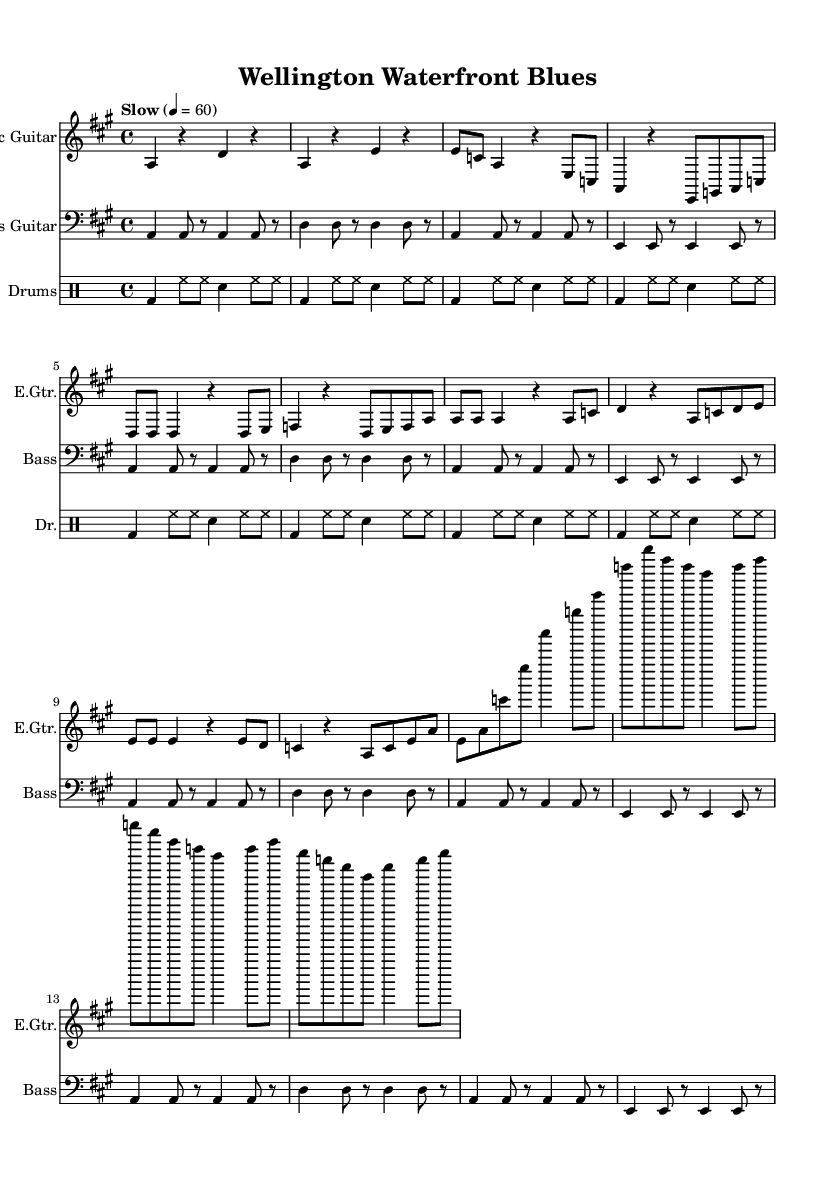What is the key signature of this music? The key signature of this music is A major, which has three sharps: F sharp, C sharp, and G sharp.
Answer: A major What is the time signature of the piece? The time signature indicated in the music is 4/4, meaning there are four beats in each measure and the quarter note gets one beat.
Answer: 4/4 What is the tempo marking for the piece? The tempo marking given is "Slow" with a metronomic tempo of 60 beats per minute, indicating a relaxed pace for playing the music.
Answer: Slow How many measures are in the guitar solo section? The guitar solo section consists of 4 measures, as indicated by the sequence of notes and rests after the chorus. Each set of bar lines separates the measures.
Answer: 4 Which instruments are included in this arrangement? The arrangement includes Electric Guitar, Bass Guitar, and Drums, as indicated by their respective instrument titles at the beginning of each staff.
Answer: Electric Guitar, Bass Guitar, Drums What is the overall structure of the piece? The piece follows a structure of Intro, Verse, Chorus, and Guitar Solo, each denoted by the arrangement of musical sections that repeat or vary throughout.
Answer: Intro, Verse, Chorus, Guitar Solo What type of blues is this music categorized as? This music is categorized as Electric Blues, a genre characterized by the use of electric instruments and a laid-back feel suitable for relaxation, which connects to the theme of relaxing by Wellington’s waterfront.
Answer: Electric Blues 